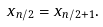<formula> <loc_0><loc_0><loc_500><loc_500>x _ { n / 2 } = x _ { n / 2 + 1 } .</formula> 